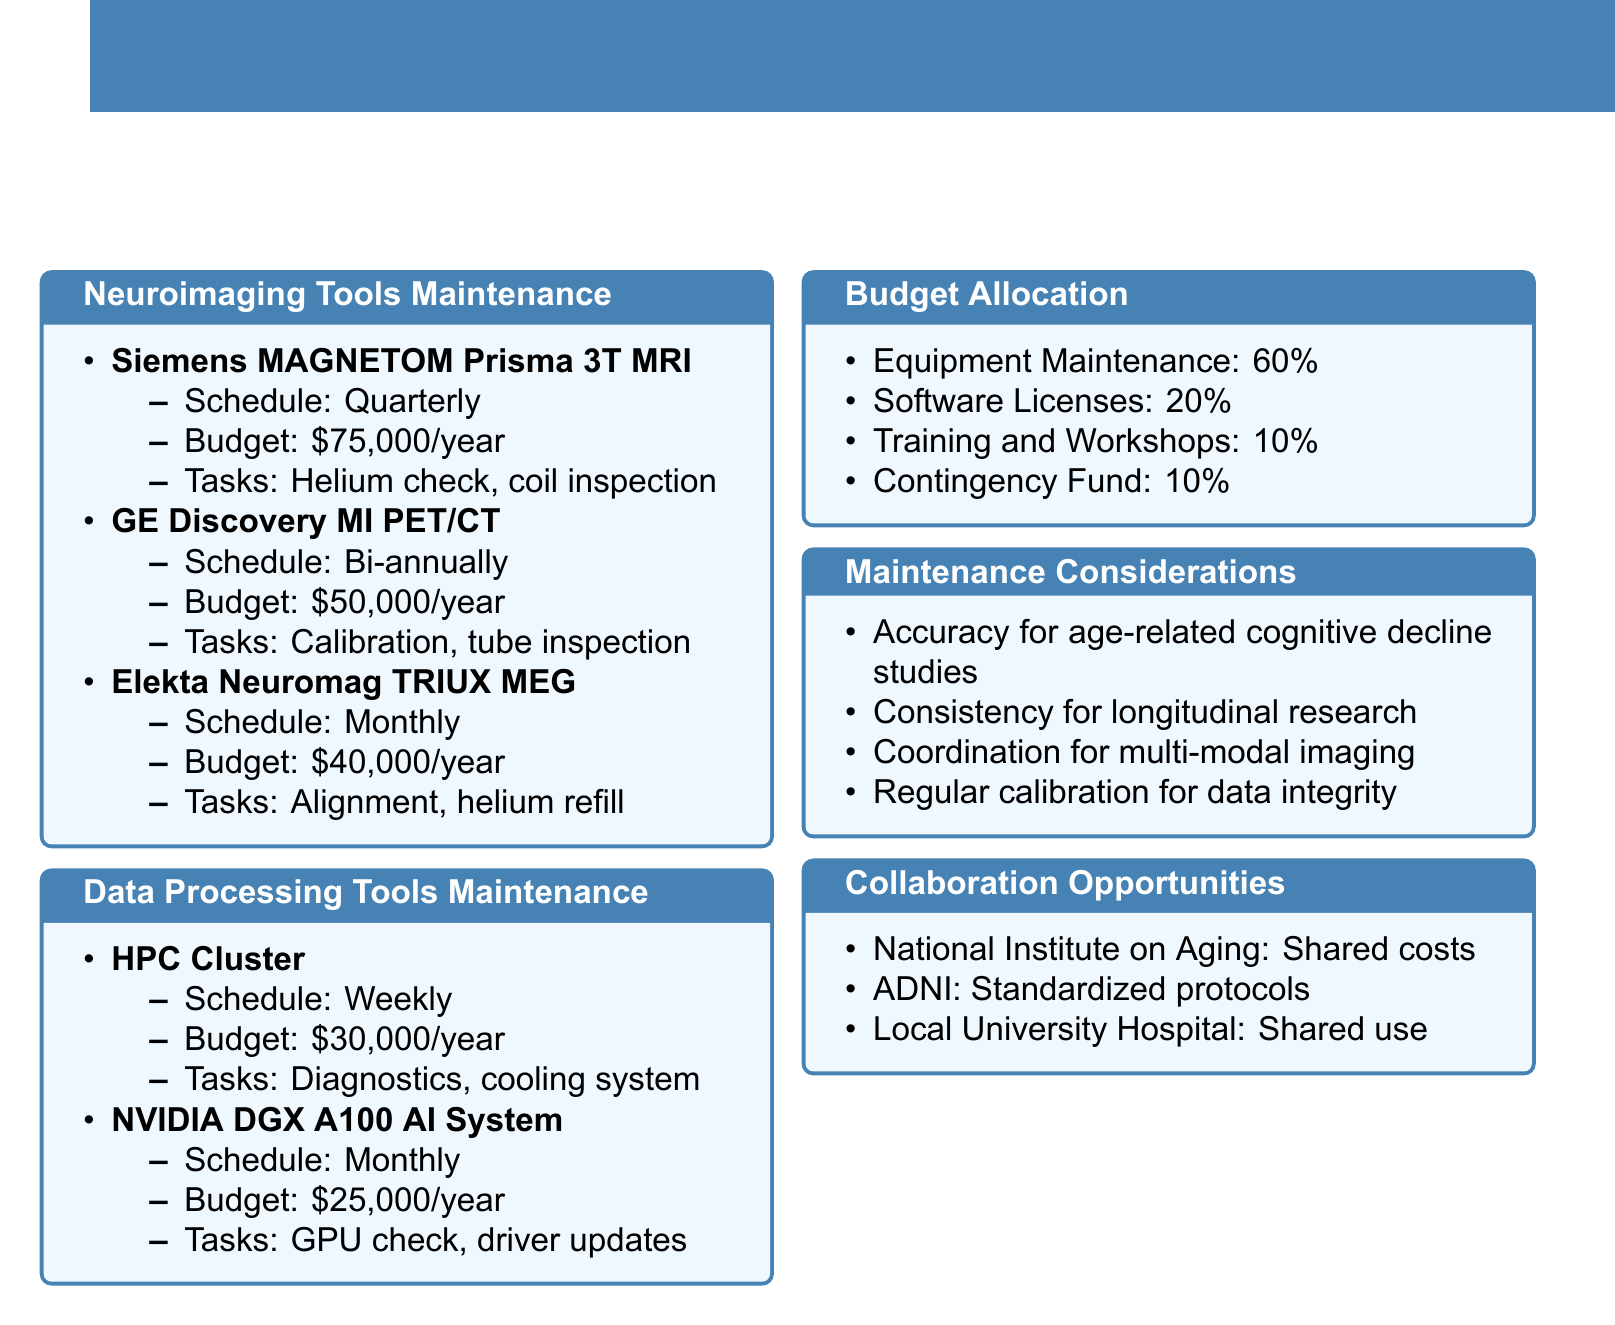What is the maintenance schedule for Siemens MAGNETOM Prisma 3T MRI Scanner? The document states that the maintenance schedule for the Siemens MAGNETOM Prisma 3T MRI Scanner is quarterly.
Answer: Quarterly How much is the annual budget for GE Discovery MI PET/CT Scanner? The annual budget for the GE Discovery MI PET/CT Scanner is listed as fifty thousand dollars.
Answer: $50,000 What percentage of the budget is allocated to equipment maintenance? The document indicates that 60% is allocated to equipment maintenance.
Answer: 60% What are the tasks involved in the maintenance of Elekta Neuromag TRIUX MEG System? The tasks for maintaining the Elekta Neuromag TRIUX MEG System include sensor alignment check, liquid helium refill, noise reduction system inspection, and software patches and updates.
Answer: Sensor alignment check, liquid helium refill, noise reduction system inspection, software patches and updates Which partner is suggested for shared maintenance costs of expensive neuroimaging equipment? The document mentions the National Institute on Aging as a partner for shared maintenance costs.
Answer: National Institute on Aging Why is regular calibration important according to maintenance considerations? Regular calibration is essential for ensuring data integrity in aging and memory research findings.
Answer: Data integrity What is the annual budget for High-Performance Computing Cluster maintenance? The annual budget for the High-Performance Computing Cluster is stated as thirty thousand dollars.
Answer: $30,000 What is the justification for allocating 10% of the budget to training and workshops? The justification provided is that it is necessary for keeping staff updated on the latest neuroimaging techniques and analysis methods.
Answer: Necessary for keeping staff updated What is the maintenance frequency for the NVIDIA DGX A100 AI System? The document specifies that the maintenance frequency for the NVIDIA DGX A100 AI System is monthly.
Answer: Monthly 